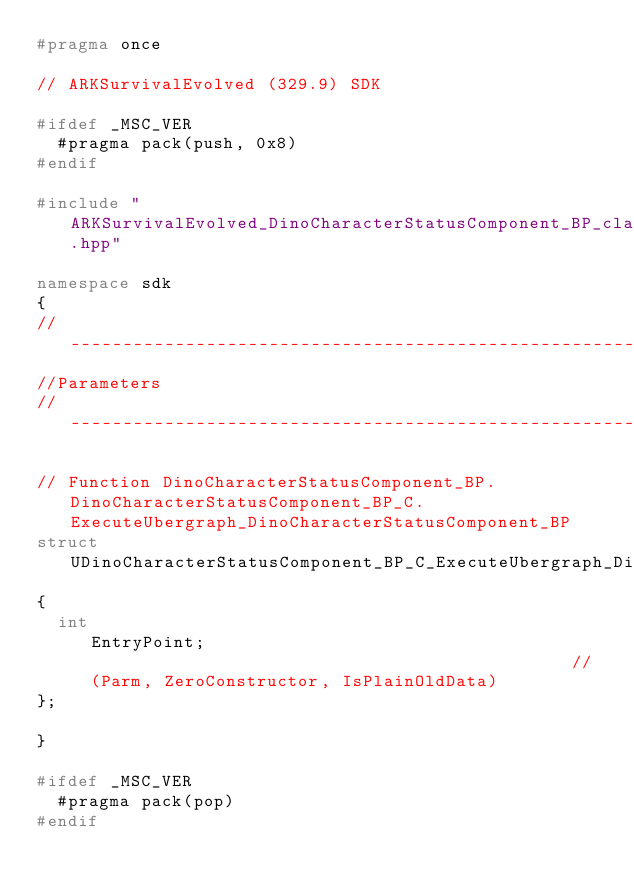Convert code to text. <code><loc_0><loc_0><loc_500><loc_500><_C++_>#pragma once

// ARKSurvivalEvolved (329.9) SDK

#ifdef _MSC_VER
	#pragma pack(push, 0x8)
#endif

#include "ARKSurvivalEvolved_DinoCharacterStatusComponent_BP_classes.hpp"

namespace sdk
{
//---------------------------------------------------------------------------
//Parameters
//---------------------------------------------------------------------------

// Function DinoCharacterStatusComponent_BP.DinoCharacterStatusComponent_BP_C.ExecuteUbergraph_DinoCharacterStatusComponent_BP
struct UDinoCharacterStatusComponent_BP_C_ExecuteUbergraph_DinoCharacterStatusComponent_BP_Params
{
	int                                                EntryPoint;                                               // (Parm, ZeroConstructor, IsPlainOldData)
};

}

#ifdef _MSC_VER
	#pragma pack(pop)
#endif
</code> 